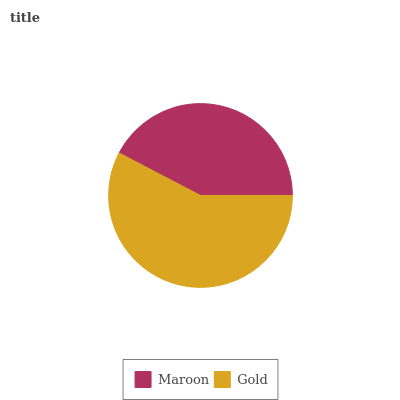Is Maroon the minimum?
Answer yes or no. Yes. Is Gold the maximum?
Answer yes or no. Yes. Is Gold the minimum?
Answer yes or no. No. Is Gold greater than Maroon?
Answer yes or no. Yes. Is Maroon less than Gold?
Answer yes or no. Yes. Is Maroon greater than Gold?
Answer yes or no. No. Is Gold less than Maroon?
Answer yes or no. No. Is Gold the high median?
Answer yes or no. Yes. Is Maroon the low median?
Answer yes or no. Yes. Is Maroon the high median?
Answer yes or no. No. Is Gold the low median?
Answer yes or no. No. 